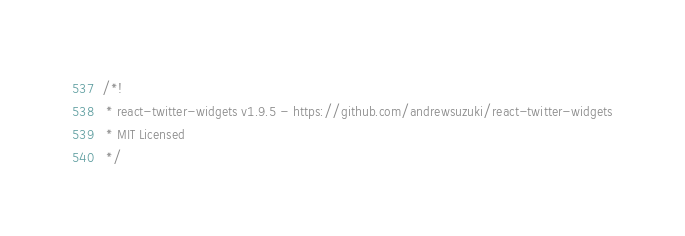Convert code to text. <code><loc_0><loc_0><loc_500><loc_500><_JavaScript_>/*!
 * react-twitter-widgets v1.9.5 - https://github.com/andrewsuzuki/react-twitter-widgets
 * MIT Licensed
 */</code> 